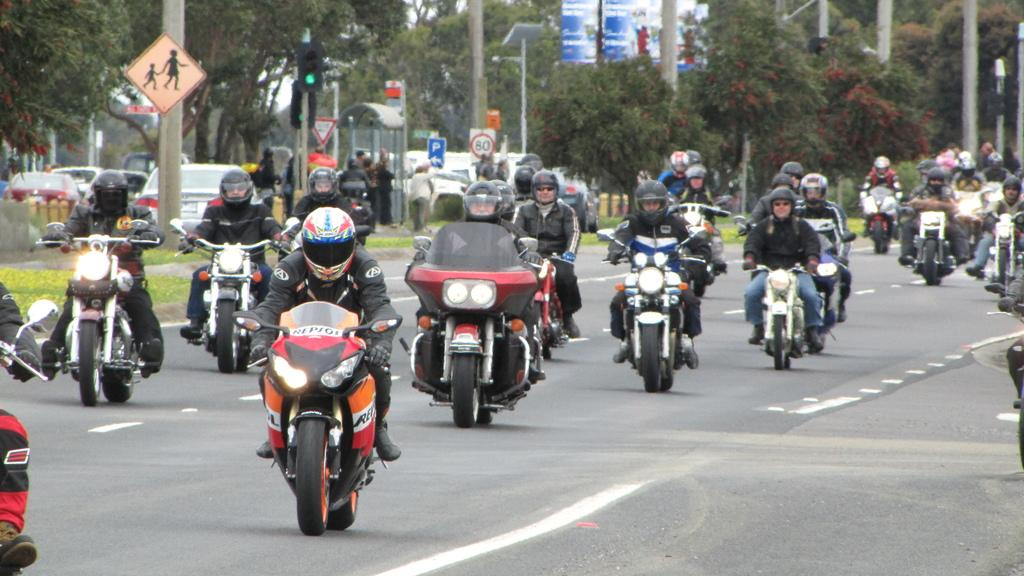What are the people in the image doing? The people in the image are riding bikes. What else can be seen in the image besides the people on bikes? There are vehicles, signals, sign boards, and poles in the image. What might be used to regulate traffic in the image? The signals in the image might be used to regulate traffic. What can be seen in the background of the image? There are trees in the background of the image. How can the calculator be used to increase the speed of the bikes in the image? There is no calculator present in the image, and therefore it cannot be used to increase the speed of the bikes. 